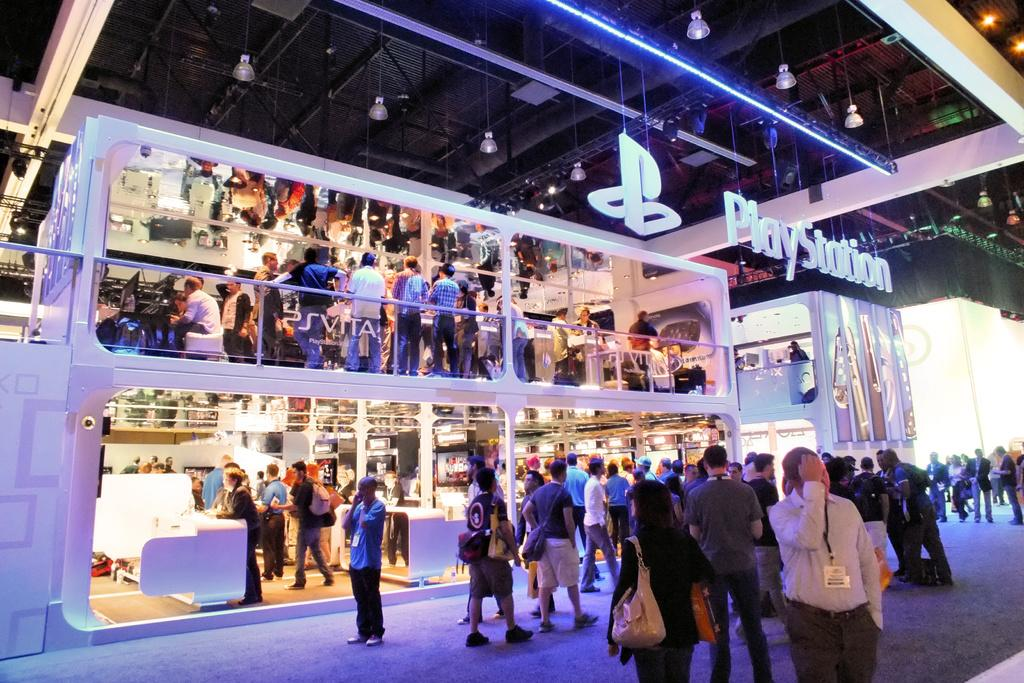How many people are in the image? There are persons in the image, but the exact number is not specified. What are the persons wearing? The persons are wearing clothes. What can be seen hanging from the ceiling in the image? There are lights hanging from the ceiling in the image. Where is the ceiling located in the image? The ceiling is at the top of the image. What type of mountain can be seen in the background of the image? There is no mountain visible in the image. Is there any rain falling in the image? There is no mention of rain in the image. 